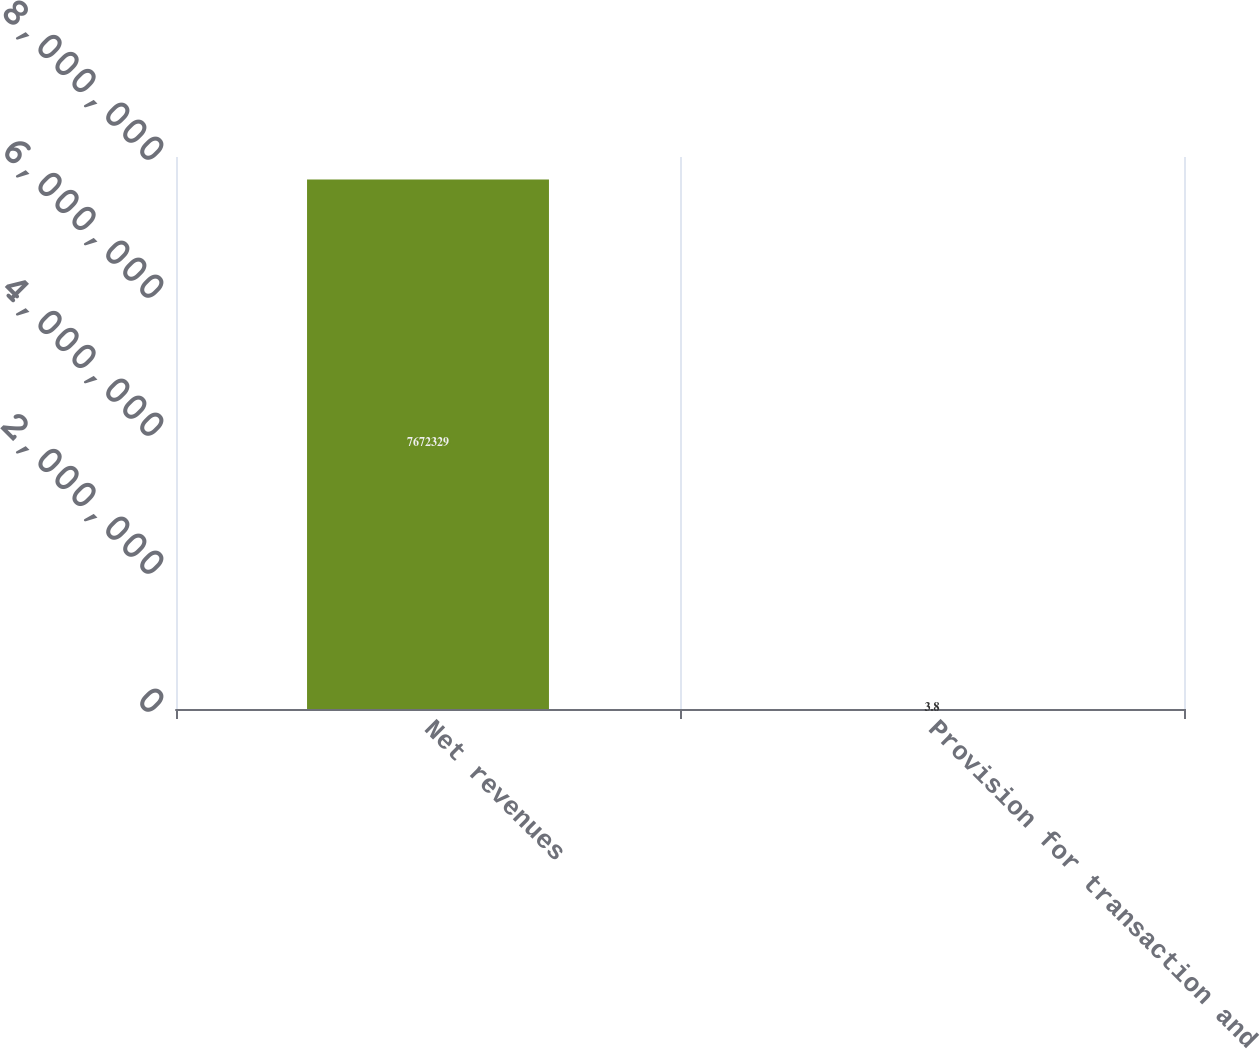Convert chart. <chart><loc_0><loc_0><loc_500><loc_500><bar_chart><fcel>Net revenues<fcel>Provision for transaction and<nl><fcel>7.67233e+06<fcel>3.8<nl></chart> 